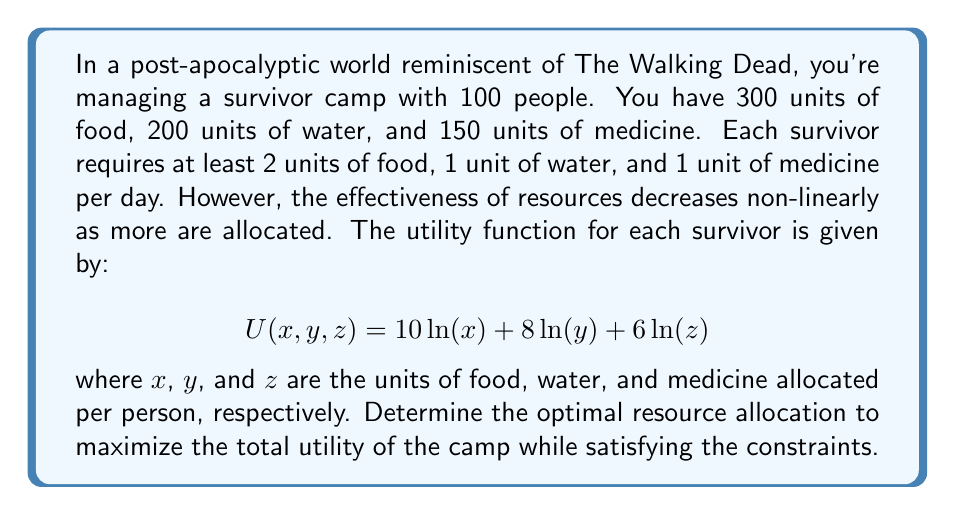Can you answer this question? To solve this problem, we'll use the method of Lagrange multipliers for constrained optimization. Let's approach this step-by-step:

1) First, we set up the objective function to maximize:
   $$ \text{Total Utility} = 100 \cdot (10\ln(x) + 8\ln(y) + 6\ln(z)) $$

2) The constraints are:
   $$ 100x \leq 300 $$
   $$ 100y \leq 200 $$
   $$ 100z \leq 150 $$
   $$ x \geq 2, y \geq 1, z \geq 1 $$

3) We form the Lagrangian function:
   $$ L = 100(10\ln(x) + 8\ln(y) + 6\ln(z)) - \lambda_1(100x - 300) - \lambda_2(100y - 200) - \lambda_3(100z - 150) $$

4) We take partial derivatives and set them to zero:
   $$ \frac{\partial L}{\partial x} = \frac{1000}{x} - 100\lambda_1 = 0 $$
   $$ \frac{\partial L}{\partial y} = \frac{800}{y} - 100\lambda_2 = 0 $$
   $$ \frac{\partial L}{\partial z} = \frac{600}{z} - 100\lambda_3 = 0 $$

5) From these, we get:
   $$ x = \frac{10}{\lambda_1}, y = \frac{8}{\lambda_2}, z = \frac{6}{\lambda_3} $$

6) Substituting these into the constraint equations:
   $$ 1000 = 300\lambda_1, 800 = 200\lambda_2, 600 = 150\lambda_3 $$

7) Solving these:
   $$ \lambda_1 = \frac{10}{3}, \lambda_2 = 4, \lambda_3 = 4 $$

8) Finally, we can solve for x, y, and z:
   $$ x = 3, y = 2, z = 1.5 $$

9) We verify that these satisfy the minimum requirements and resource constraints.

Therefore, the optimal allocation is 3 units of food, 2 units of water, and 1.5 units of medicine per person per day.
Answer: (3, 2, 1.5) 